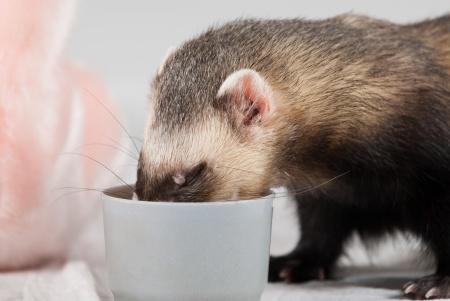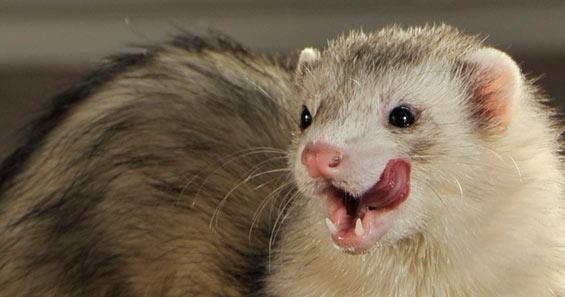The first image is the image on the left, the second image is the image on the right. Assess this claim about the two images: "A ferret with no food in front of it is """"licking its chops"""" with an upturned tongue.". Correct or not? Answer yes or no. Yes. The first image is the image on the left, the second image is the image on the right. Considering the images on both sides, is "The little animal in one image has its mouth wide open with tongue and two lower teeth showing, while a second little animal is eating in the second image." valid? Answer yes or no. Yes. 